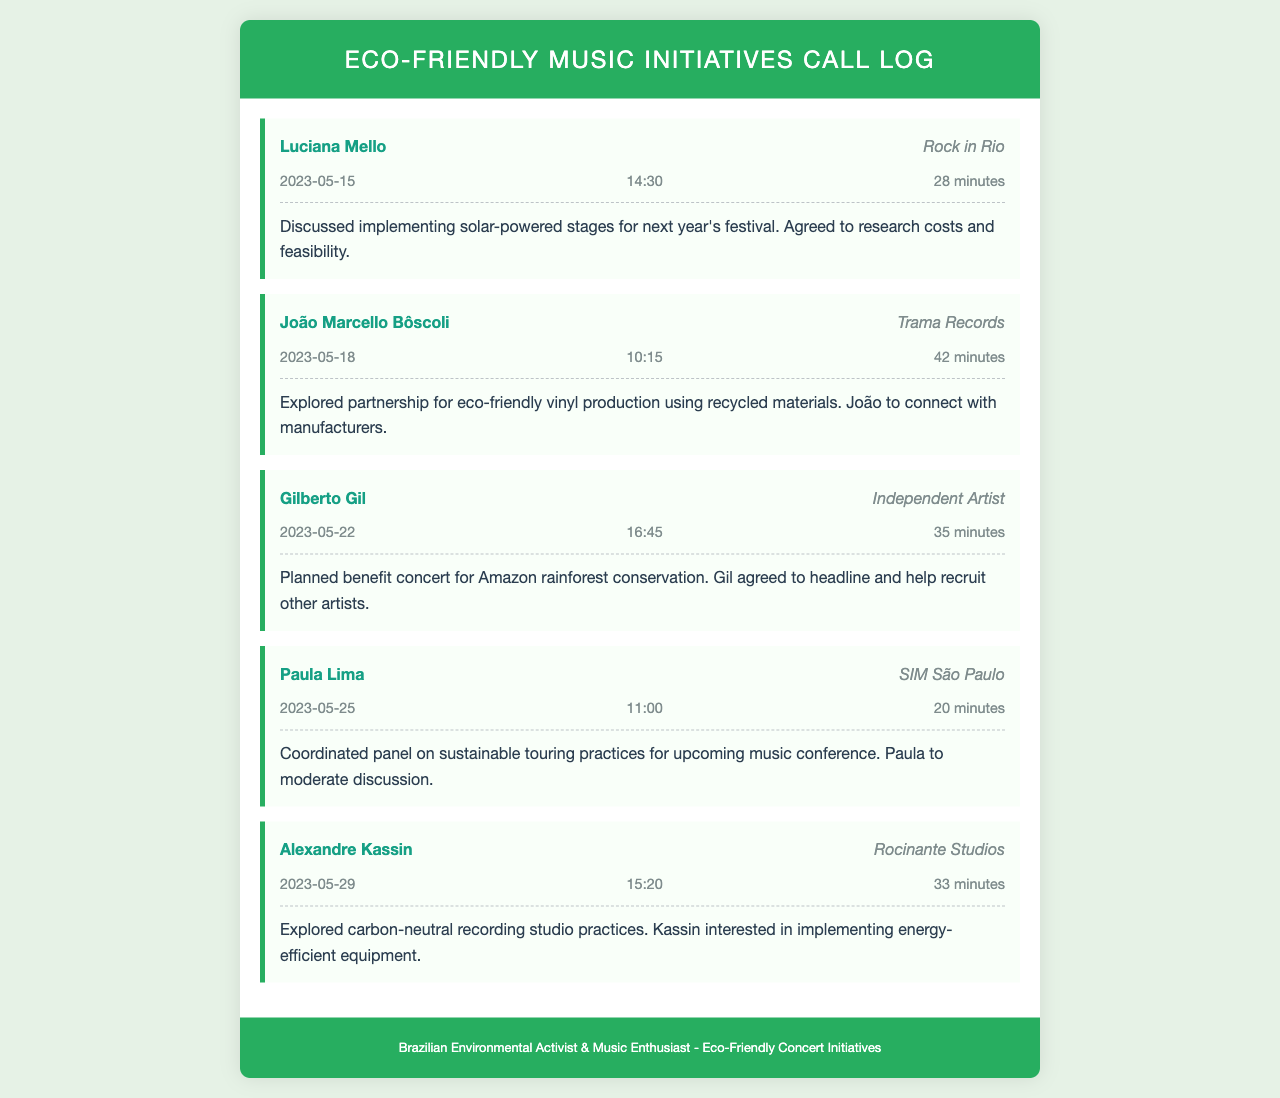What is the name of the first contact? The first contact listed in the call log is Luciana Mello.
Answer: Luciana Mello What organization is João Marcello Bôscoli associated with? João Marcello Bôscoli is associated with Trama Records.
Answer: Trama Records On what date did Gilberto Gil have a call? Gilberto Gil had a call on May 22, 2023.
Answer: May 22, 2023 How long was the call with Paula Lima? The call with Paula Lima lasted for 20 minutes.
Answer: 20 minutes What initiative was discussed in the call with Luciana Mello? In the call with Luciana Mello, they discussed implementing solar-powered stages.
Answer: solar-powered stages Who is responsible for moderating the sustainable touring discussion? Paula Lima is responsible for moderating the discussion on sustainable touring practices.
Answer: Paula Lima What is the topic of the benefit concert planned with Gilberto Gil? The topic of the benefit concert is Amazon rainforest conservation.
Answer: Amazon rainforest conservation How many calls were made in total? There were five calls made in total.
Answer: five What is Alexandre Kassin interested in implementing? Alexandre Kassin is interested in implementing energy-efficient equipment.
Answer: energy-efficient equipment 